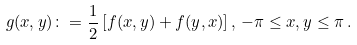Convert formula to latex. <formula><loc_0><loc_0><loc_500><loc_500>g ( x , y ) \colon = \frac { 1 } { 2 } \left [ f ( x , y ) + f ( y , x ) \right ] , \, - \pi \leq x , y \leq \pi \, .</formula> 